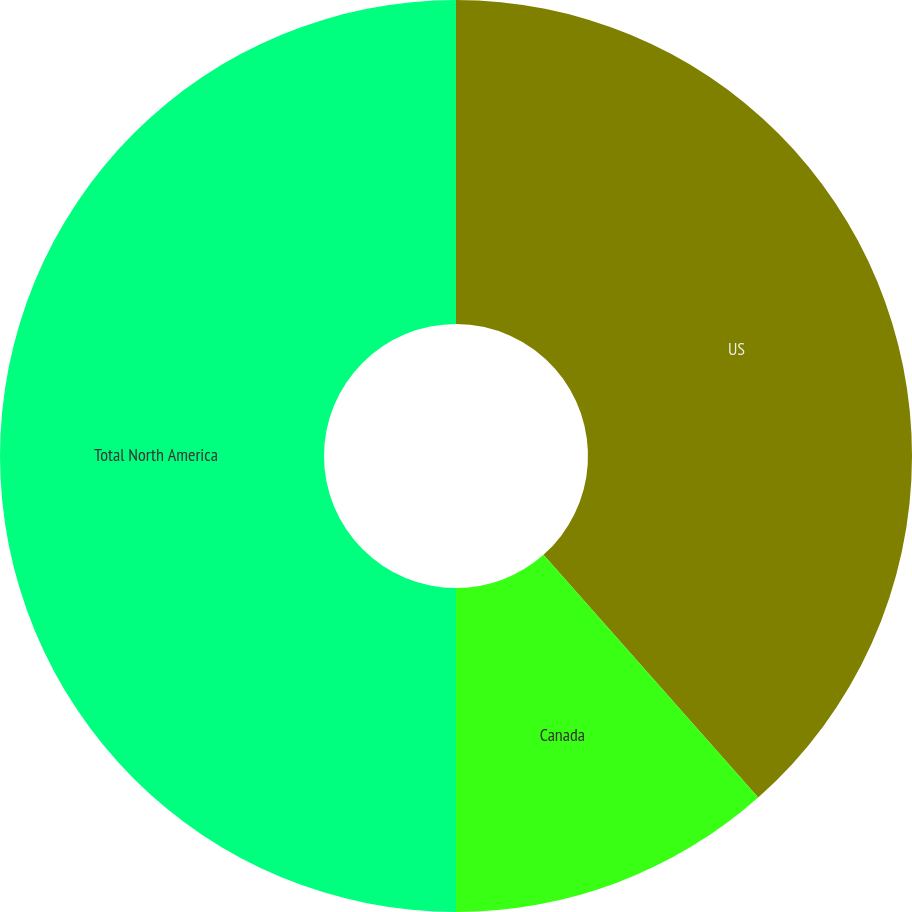Convert chart to OTSL. <chart><loc_0><loc_0><loc_500><loc_500><pie_chart><fcel>US<fcel>Canada<fcel>Total North America<nl><fcel>38.47%<fcel>11.53%<fcel>50.0%<nl></chart> 